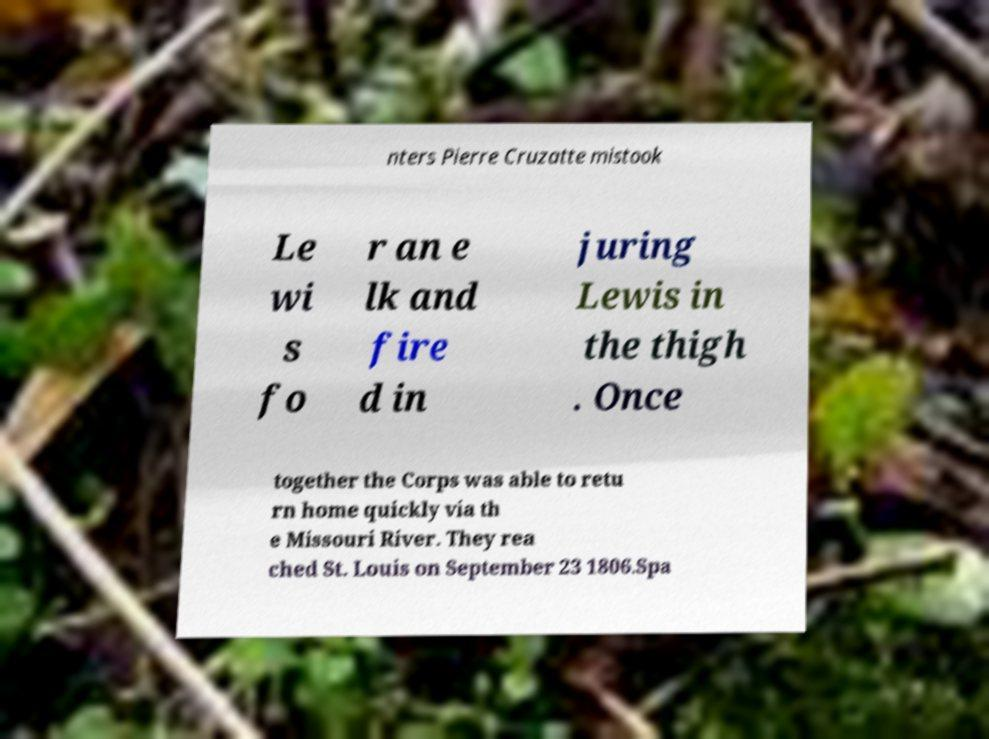For documentation purposes, I need the text within this image transcribed. Could you provide that? nters Pierre Cruzatte mistook Le wi s fo r an e lk and fire d in juring Lewis in the thigh . Once together the Corps was able to retu rn home quickly via th e Missouri River. They rea ched St. Louis on September 23 1806.Spa 